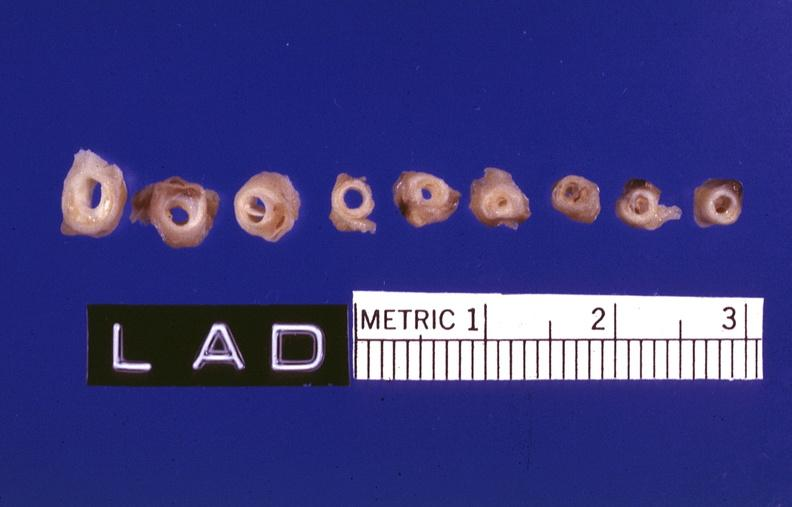how is atherosclerosis left anterior descending artery?
Answer the question using a single word or phrase. Coronary 